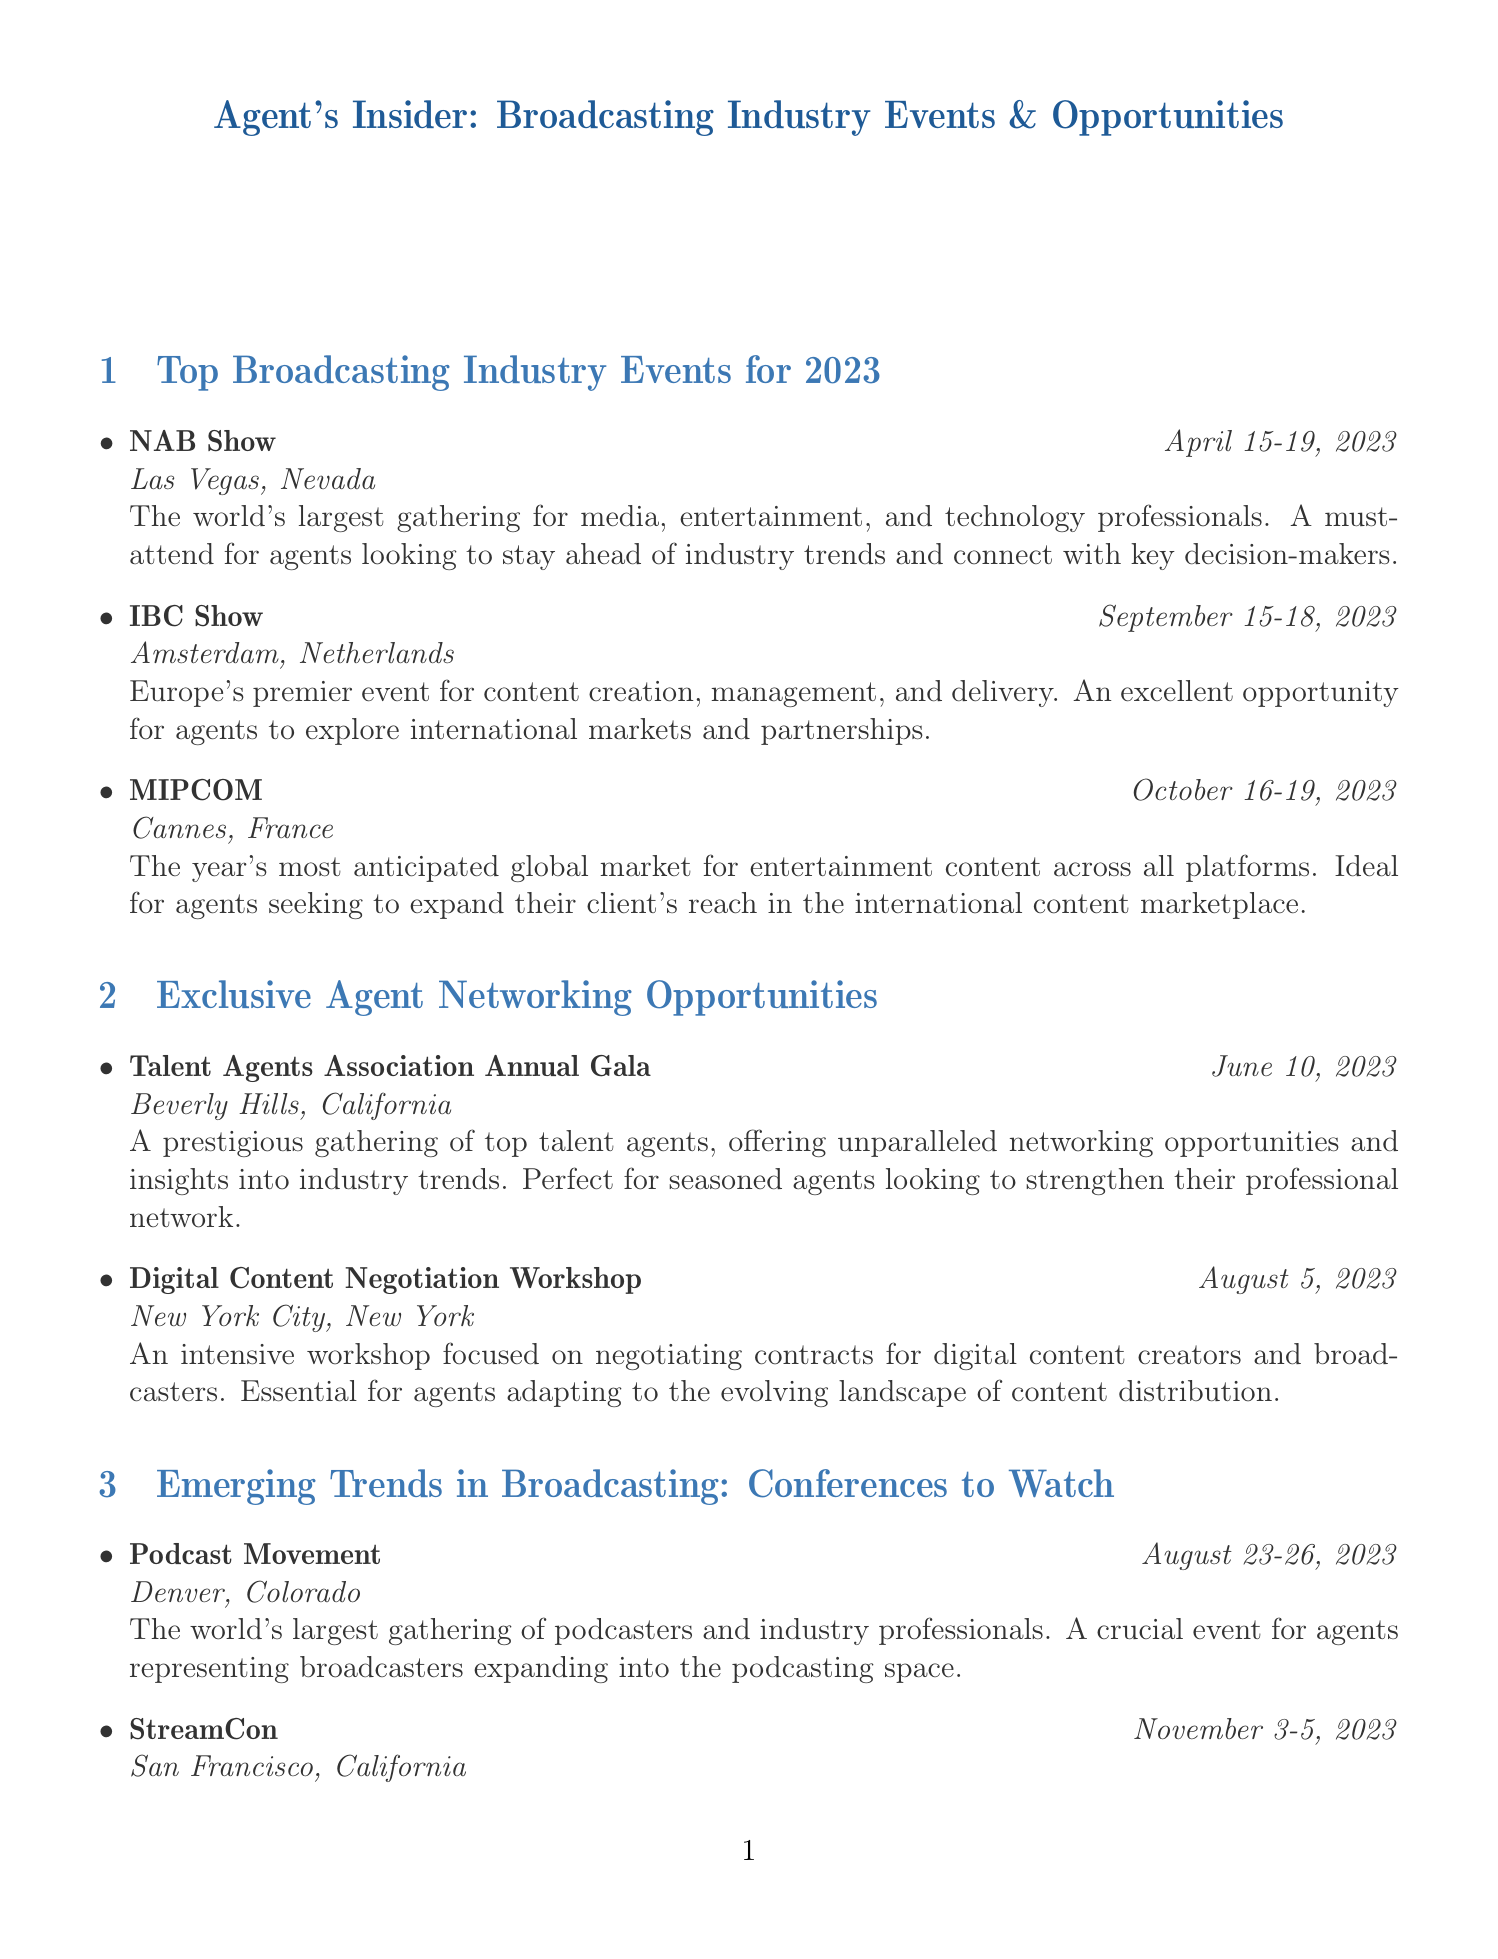What is the date of the NAB Show? The NAB Show is scheduled for April 15-19, 2023, as stated in the document.
Answer: April 15-19, 2023 Where is the IBC Show taking place? The IBC Show will be held in Amsterdam, Netherlands, according to the document.
Answer: Amsterdam, Netherlands What event is focused on the podcasting space? Podcast Movement is identified in the document as the largest gathering of podcasters and industry professionals.
Answer: Podcast Movement What is the location of the Talent Agents Association Annual Gala? The document specifies that the gala will take place in Beverly Hills, California.
Answer: Beverly Hills, California What is the organizer of the Advanced Media Contract Negotiation Seminar? The document states that this seminar is organized by the American Bar Association.
Answer: American Bar Association How many days does the StreamCon conference last? StreamCon is scheduled to occur from November 3-5, 2023, which spans three days.
Answer: Three days Which event focuses on international broadcasting rights? The International Broadcasting Rights Symposium in London is detailed in the document as focusing on this area.
Answer: International Broadcasting Rights Symposium What is the purpose of the Digital Content Negotiation Workshop? The document describes it as focused on negotiating contracts for digital content creators and broadcasters.
Answer: Negotiating contracts for digital content creators and broadcasters What type of gathering is described for the Talent Agents Association Annual Gala? The gala is described as a prestigious gathering of top talent agents in the document.
Answer: Prestigious gathering of top talent agents 